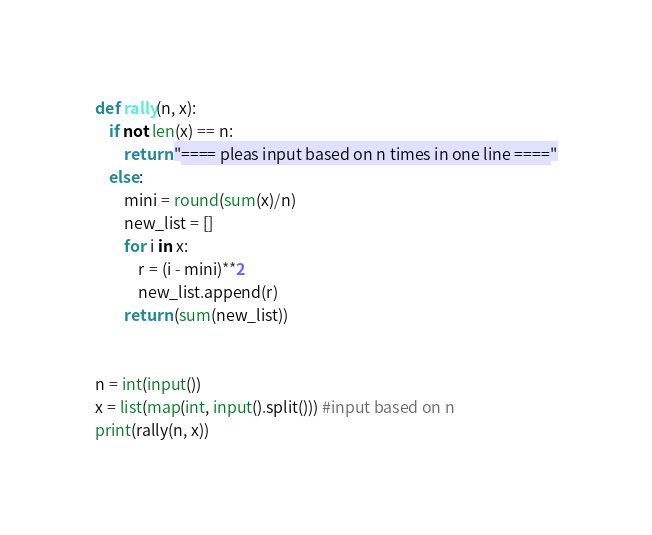<code> <loc_0><loc_0><loc_500><loc_500><_Python_>def rally(n, x):
    if not len(x) == n:
        return "==== pleas input based on n times in one line ===="
    else:
        mini = round(sum(x)/n)
        new_list = []
        for i in x:
            r = (i - mini)**2
            new_list.append(r)
        return (sum(new_list))


n = int(input())
x = list(map(int, input().split())) #input based on n
print(rally(n, x))

</code> 